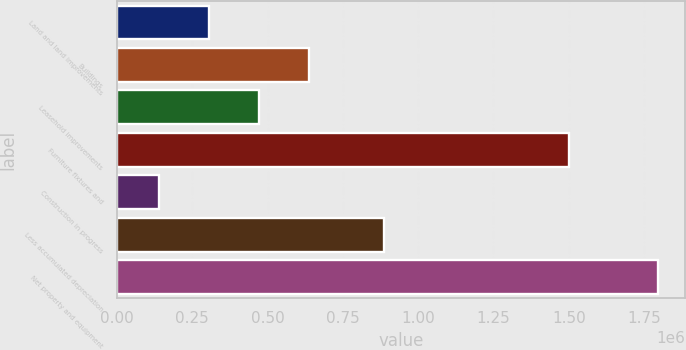<chart> <loc_0><loc_0><loc_500><loc_500><bar_chart><fcel>Land and land improvements<fcel>Buildings<fcel>Leasehold improvements<fcel>Furniture fixtures and<fcel>Construction in progress<fcel>Less accumulated depreciation<fcel>Net property and equipment<nl><fcel>305005<fcel>636106<fcel>470555<fcel>1.50027e+06<fcel>139454<fcel>886025<fcel>1.79496e+06<nl></chart> 